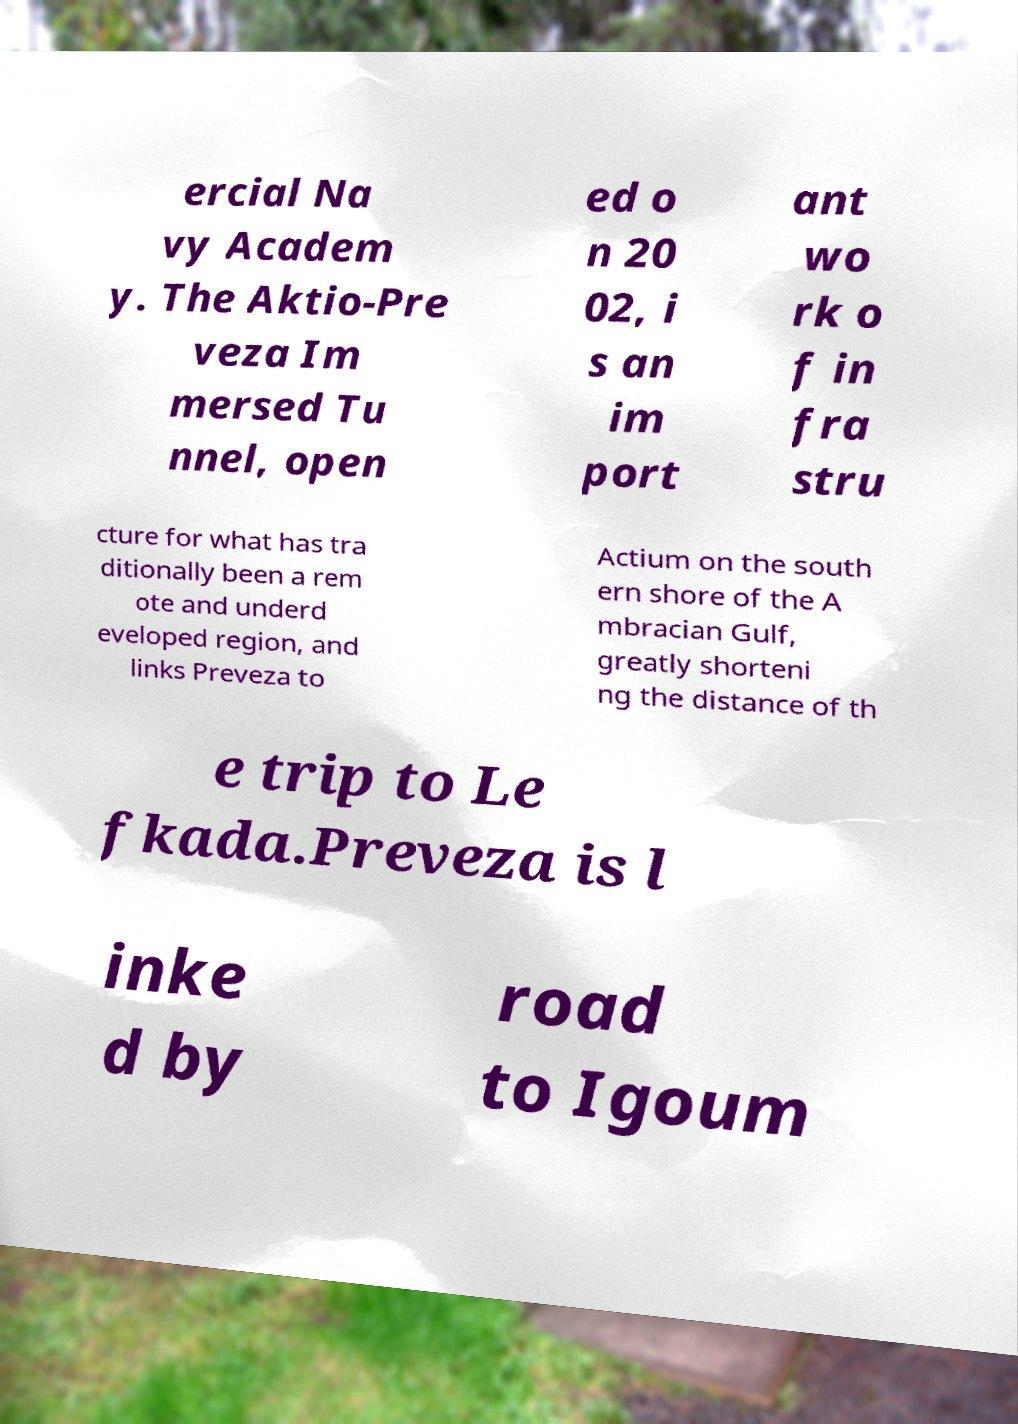Can you accurately transcribe the text from the provided image for me? ercial Na vy Academ y. The Aktio-Pre veza Im mersed Tu nnel, open ed o n 20 02, i s an im port ant wo rk o f in fra stru cture for what has tra ditionally been a rem ote and underd eveloped region, and links Preveza to Actium on the south ern shore of the A mbracian Gulf, greatly shorteni ng the distance of th e trip to Le fkada.Preveza is l inke d by road to Igoum 